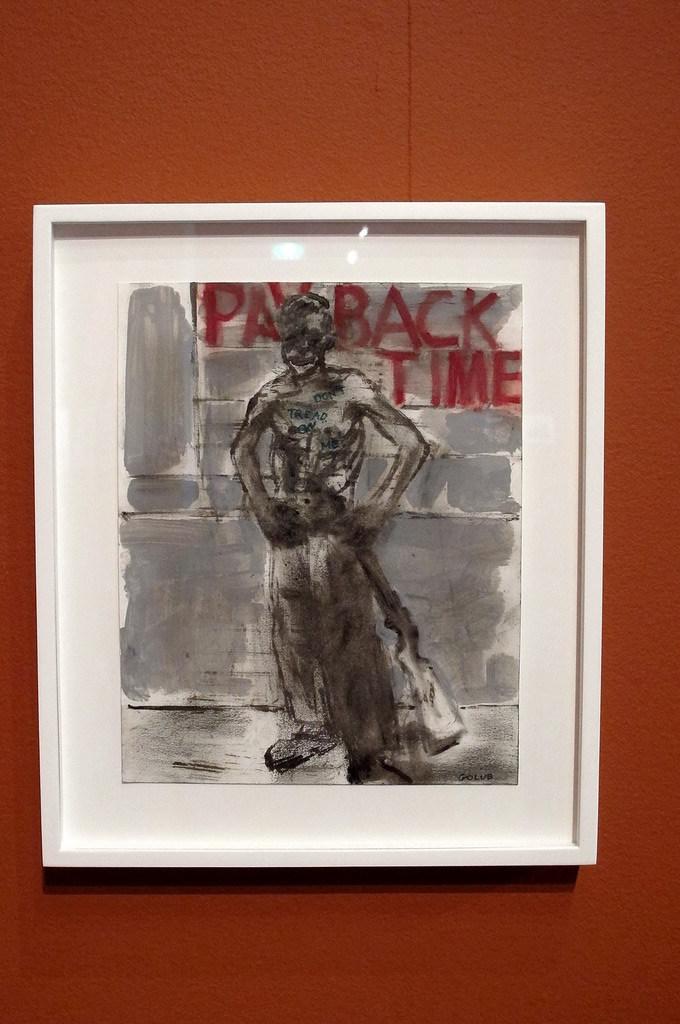What does the picture say?
Your response must be concise. Payback time. 